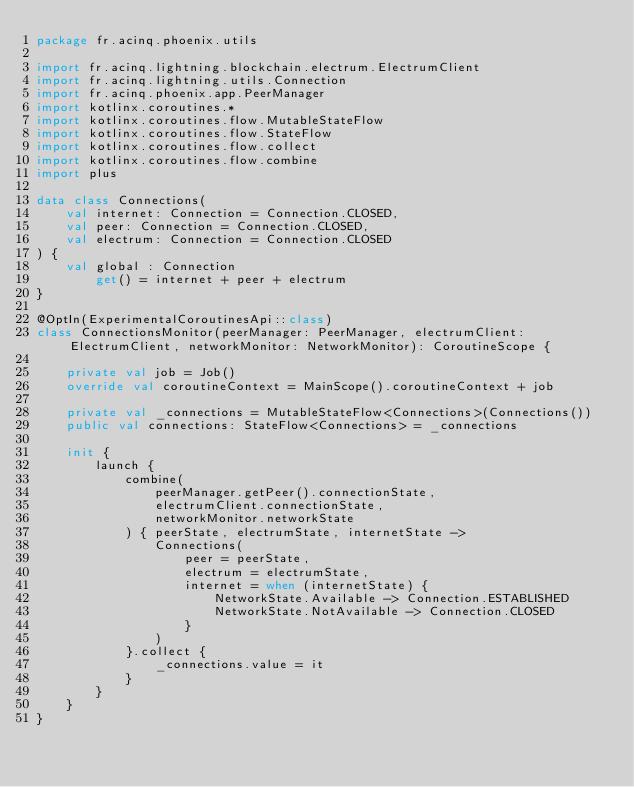Convert code to text. <code><loc_0><loc_0><loc_500><loc_500><_Kotlin_>package fr.acinq.phoenix.utils

import fr.acinq.lightning.blockchain.electrum.ElectrumClient
import fr.acinq.lightning.utils.Connection
import fr.acinq.phoenix.app.PeerManager
import kotlinx.coroutines.*
import kotlinx.coroutines.flow.MutableStateFlow
import kotlinx.coroutines.flow.StateFlow
import kotlinx.coroutines.flow.collect
import kotlinx.coroutines.flow.combine
import plus

data class Connections(
    val internet: Connection = Connection.CLOSED,
    val peer: Connection = Connection.CLOSED,
    val electrum: Connection = Connection.CLOSED
) {
    val global : Connection
        get() = internet + peer + electrum
}

@OptIn(ExperimentalCoroutinesApi::class)
class ConnectionsMonitor(peerManager: PeerManager, electrumClient: ElectrumClient, networkMonitor: NetworkMonitor): CoroutineScope {

    private val job = Job()
    override val coroutineContext = MainScope().coroutineContext + job

    private val _connections = MutableStateFlow<Connections>(Connections())
    public val connections: StateFlow<Connections> = _connections

    init {
        launch {
            combine(
                peerManager.getPeer().connectionState,
                electrumClient.connectionState,
                networkMonitor.networkState
            ) { peerState, electrumState, internetState ->
                Connections(
                    peer = peerState,
                    electrum = electrumState,
                    internet = when (internetState) {
                        NetworkState.Available -> Connection.ESTABLISHED
                        NetworkState.NotAvailable -> Connection.CLOSED
                    }
                )
            }.collect {
                _connections.value = it
            }
        }
    }
}</code> 